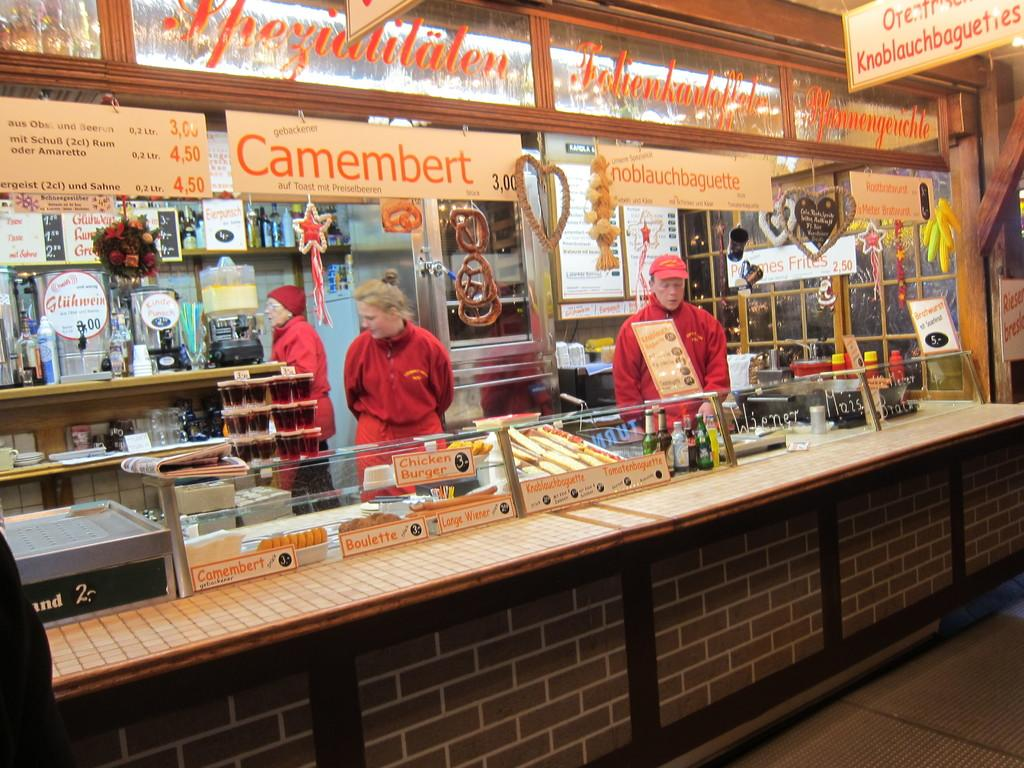<image>
Describe the image concisely. the inside of a restaurant with a camembert sign on it 